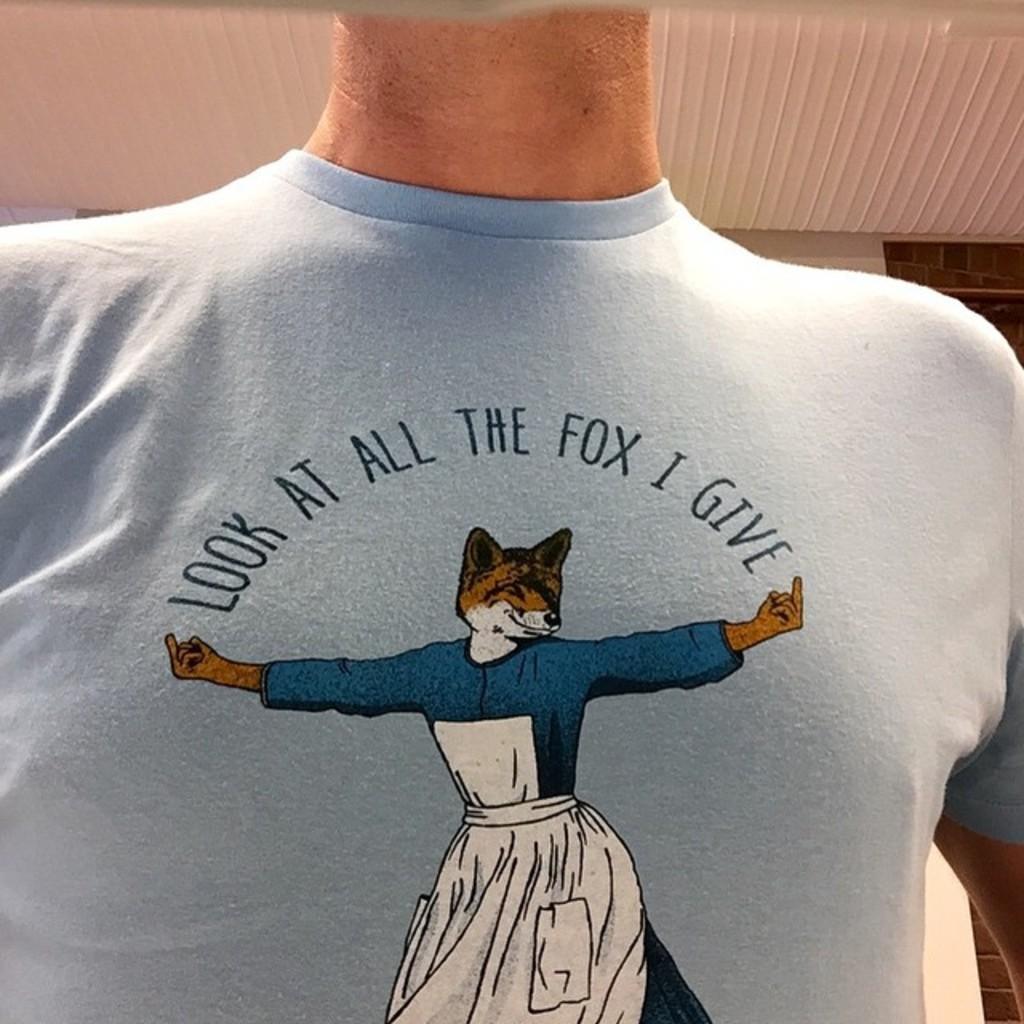In one or two sentences, can you explain what this image depicts? In this image we can see a person wearing a t shirt on which we can see a picture and some text. In the background, we can see wall and the ceiling. 